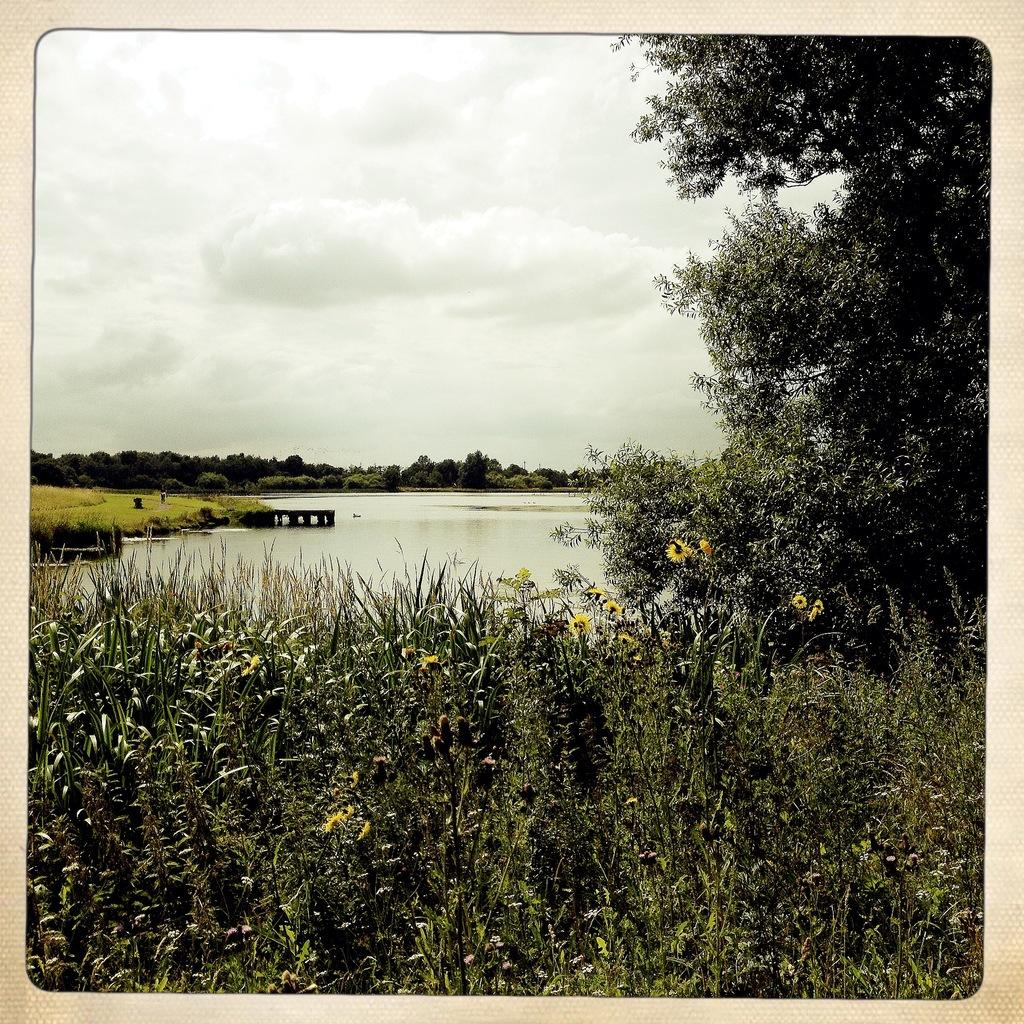What types of vegetation can be seen in the image? There are plants and flowers in the image. Where is the tree located in the image? The tree is on the right side of the image. What is the wooden object doing in the image? The wooden object is in water in the image. What can be seen in the background of the image? There are trees visible in the background of the image. How would you describe the weather in the image? The sky is cloudy in the image, suggesting a potentially overcast or rainy day. What type of spy equipment can be seen hidden among the trees in the image? There is no spy equipment visible in the image; it features plants, flowers, a tree, a wooden object in water, and a cloudy sky. How many trees are there in the image? There is one tree visible on the right side of the image, and additional trees can be seen in the background. However, counting the exact number of trees in the background is not possible from the provided facts. 